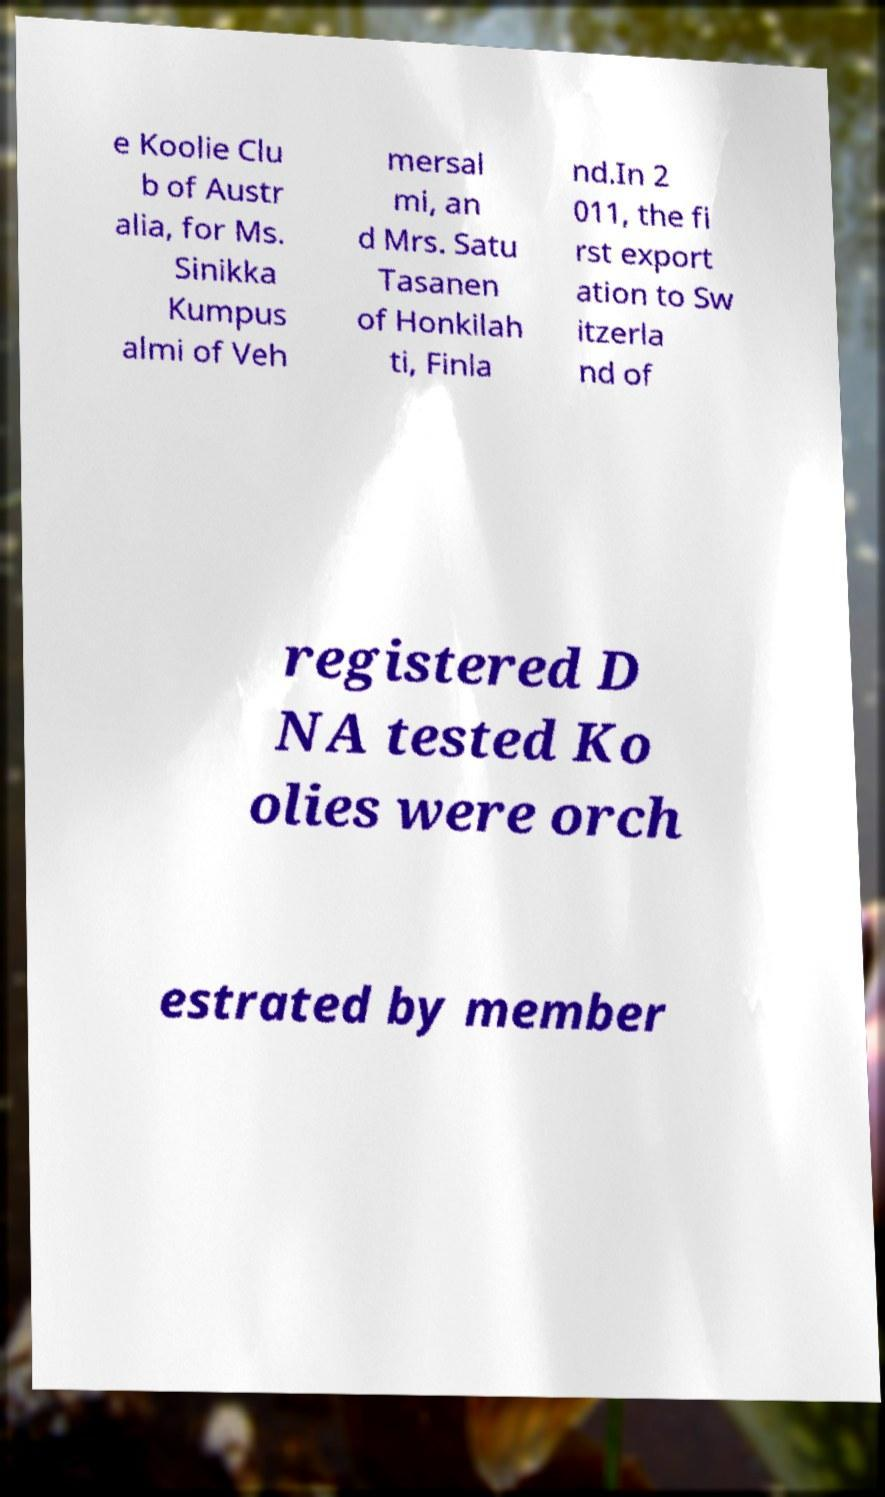There's text embedded in this image that I need extracted. Can you transcribe it verbatim? e Koolie Clu b of Austr alia, for Ms. Sinikka Kumpus almi of Veh mersal mi, an d Mrs. Satu Tasanen of Honkilah ti, Finla nd.In 2 011, the fi rst export ation to Sw itzerla nd of registered D NA tested Ko olies were orch estrated by member 